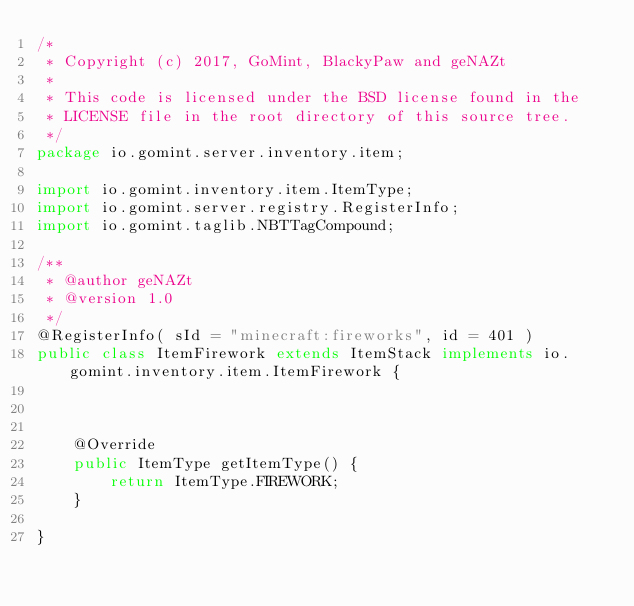<code> <loc_0><loc_0><loc_500><loc_500><_Java_>/*
 * Copyright (c) 2017, GoMint, BlackyPaw and geNAZt
 *
 * This code is licensed under the BSD license found in the
 * LICENSE file in the root directory of this source tree.
 */
package io.gomint.server.inventory.item;

import io.gomint.inventory.item.ItemType;
import io.gomint.server.registry.RegisterInfo;
import io.gomint.taglib.NBTTagCompound;

/**
 * @author geNAZt
 * @version 1.0
 */
@RegisterInfo( sId = "minecraft:fireworks", id = 401 )
public class ItemFirework extends ItemStack implements io.gomint.inventory.item.ItemFirework {



    @Override
    public ItemType getItemType() {
        return ItemType.FIREWORK;
    }

}</code> 